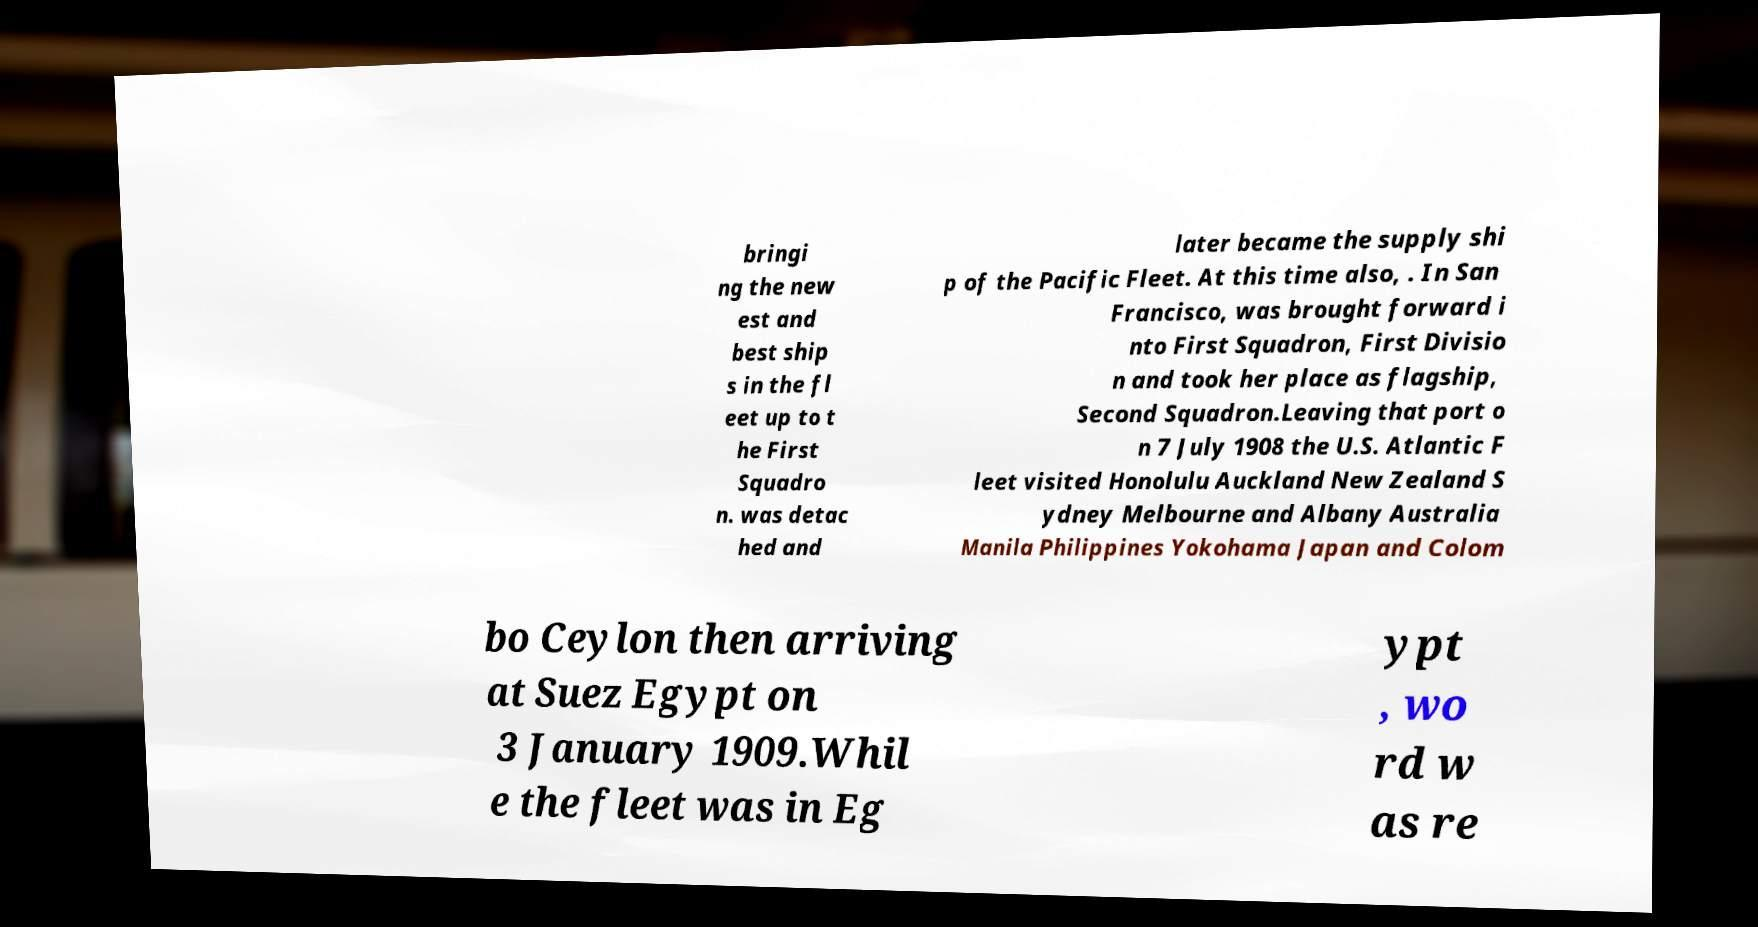Can you accurately transcribe the text from the provided image for me? bringi ng the new est and best ship s in the fl eet up to t he First Squadro n. was detac hed and later became the supply shi p of the Pacific Fleet. At this time also, . In San Francisco, was brought forward i nto First Squadron, First Divisio n and took her place as flagship, Second Squadron.Leaving that port o n 7 July 1908 the U.S. Atlantic F leet visited Honolulu Auckland New Zealand S ydney Melbourne and Albany Australia Manila Philippines Yokohama Japan and Colom bo Ceylon then arriving at Suez Egypt on 3 January 1909.Whil e the fleet was in Eg ypt , wo rd w as re 